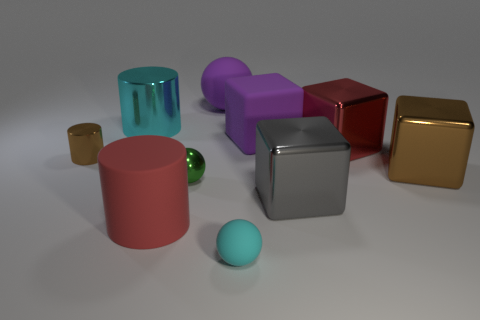What is the material of the cylinder that is in front of the cyan cylinder and behind the big brown thing?
Make the answer very short. Metal. Does the cyan matte object have the same size as the gray cube?
Ensure brevity in your answer.  No. There is a cyan object in front of the tiny metallic object that is in front of the brown cylinder; what is its size?
Make the answer very short. Small. How many objects are left of the brown shiny block and behind the small rubber thing?
Ensure brevity in your answer.  8. Is there a large purple object left of the big red thing on the left side of the small ball left of the small cyan matte sphere?
Provide a short and direct response. No. What shape is the cyan thing that is the same size as the red cylinder?
Your answer should be very brief. Cylinder. Are there any big matte objects of the same color as the small matte sphere?
Offer a very short reply. No. Is the small cyan object the same shape as the small green metal object?
Provide a succinct answer. Yes. How many large things are either purple matte balls or red shiny objects?
Provide a short and direct response. 2. What is the color of the tiny ball that is the same material as the big purple block?
Ensure brevity in your answer.  Cyan. 